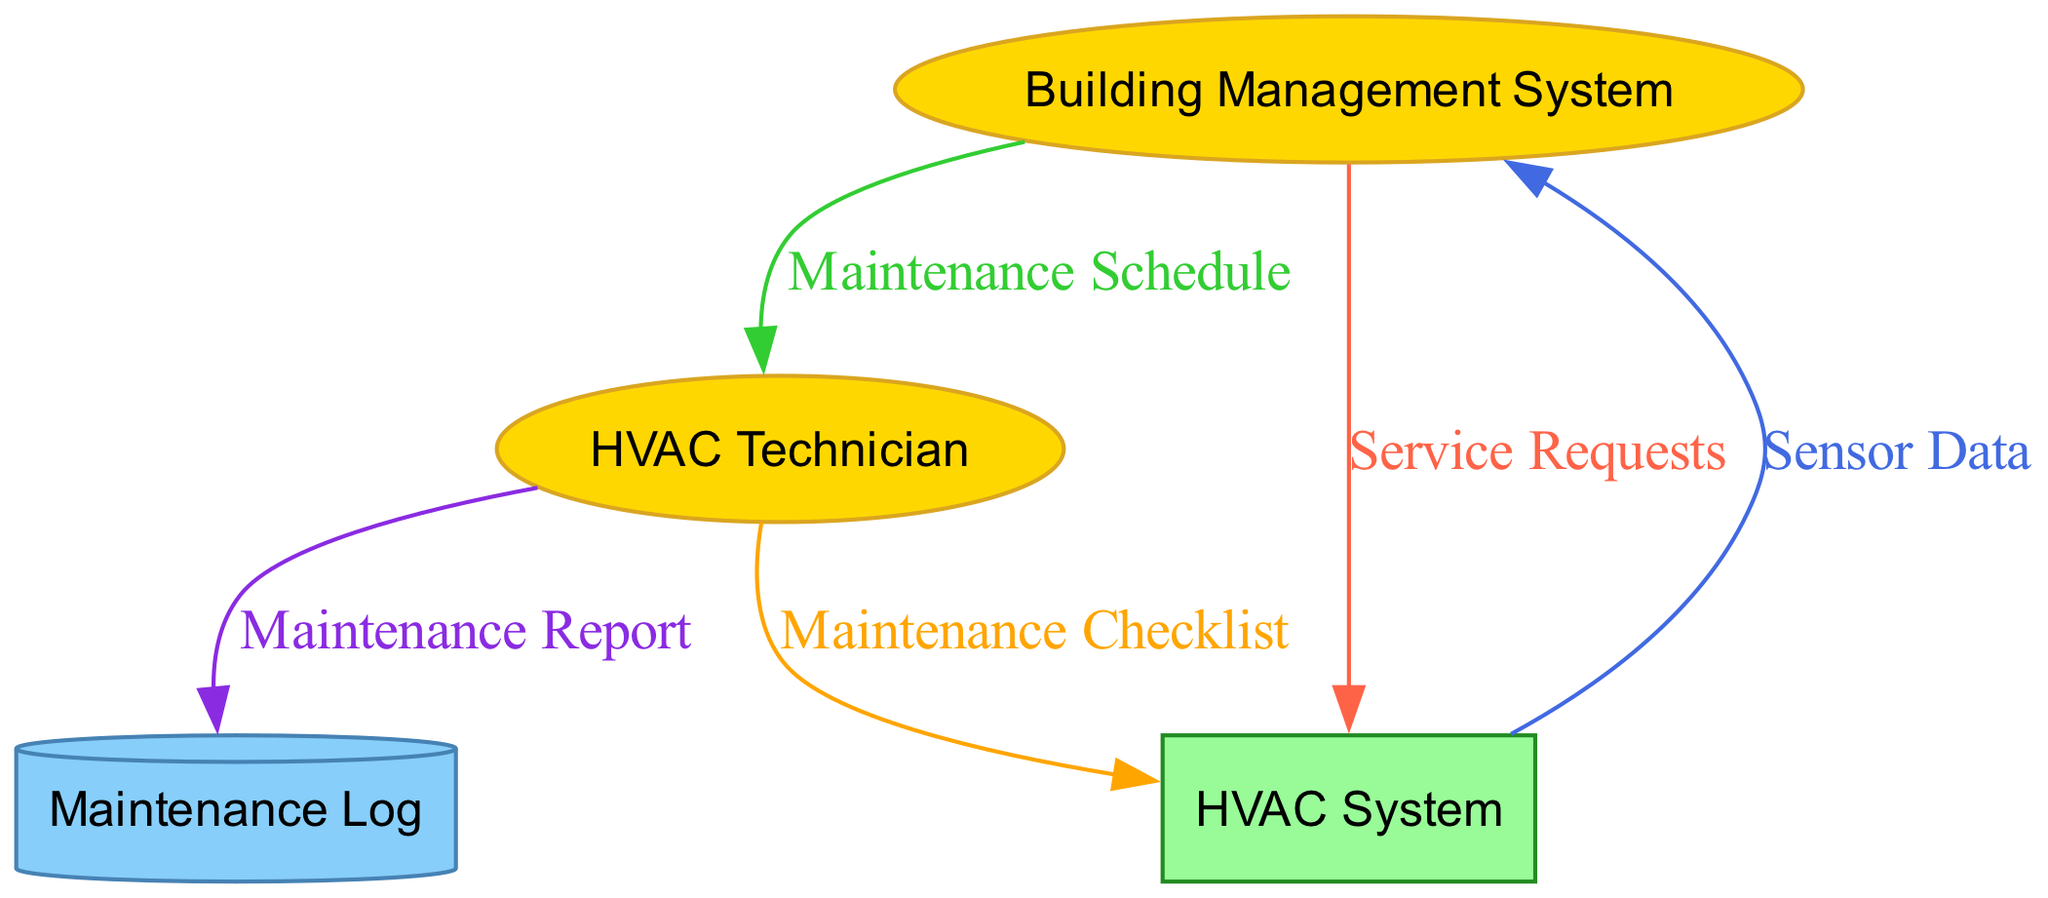What is the total number of nodes in the diagram? The diagram includes five nodes: Building Management System, HVAC Technician, HVAC System, Maintenance Log, and the Data Store. Counting them gives a total of five nodes.
Answer: five How many edges are in the workflow diagram? The workflow diagram features five edges representing the data flows: Service Requests, Sensor Data, Maintenance Schedule, Maintenance Checklist, and Maintenance Report.
Answer: five Which entity generates the Maintenance Report? The Maintenance Report is generated by the HVAC Technician after performing maintenance tasks.
Answer: HVAC Technician What type of entity is the HVAC System? The HVAC System is classified as a Process in the diagram. This is indicated by its rectangular shape.
Answer: Process What flows from the HVAC System to the Building Management System? The flow from the HVAC System to the Building Management System is labeled as Sensor Data, which represents the data collected from the HVAC system's sensors.
Answer: Sensor Data How does the Building Management System initiate the maintenance process? The Building Management System initiates the maintenance process by sending Service Requests to the HVAC System or HVAC Technician when maintenance is needed.
Answer: Service Requests What is the relationship between HVAC Technician and Maintenance Log? The relationship is that the HVAC Technician sends the Maintenance Report to the Maintenance Log after completing maintenance work, updating the database with the logged information.
Answer: Maintenance Report Which entity receives the Maintenance Schedule? The Maintenance Schedule is received by the HVAC Technician from the Building Management System, which informs them of the upcoming maintenance activities.
Answer: HVAC Technician What type of data store is represented in the diagram? The data store shown in the diagram is represented as a cylinder, specifically labeled as Maintenance Log, where all maintenance records are kept.
Answer: Maintenance Log 